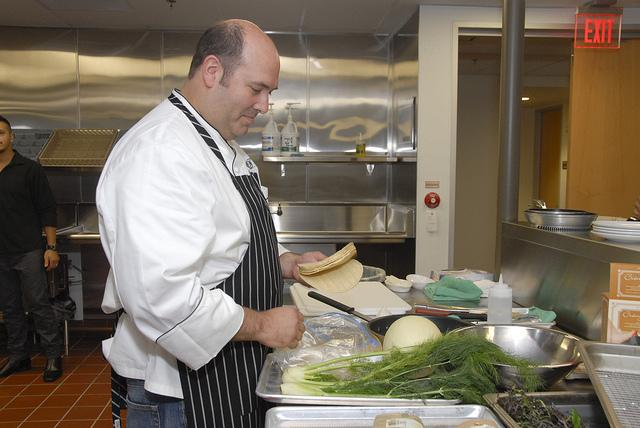What type of wrapper is he putting food in? tortilla 